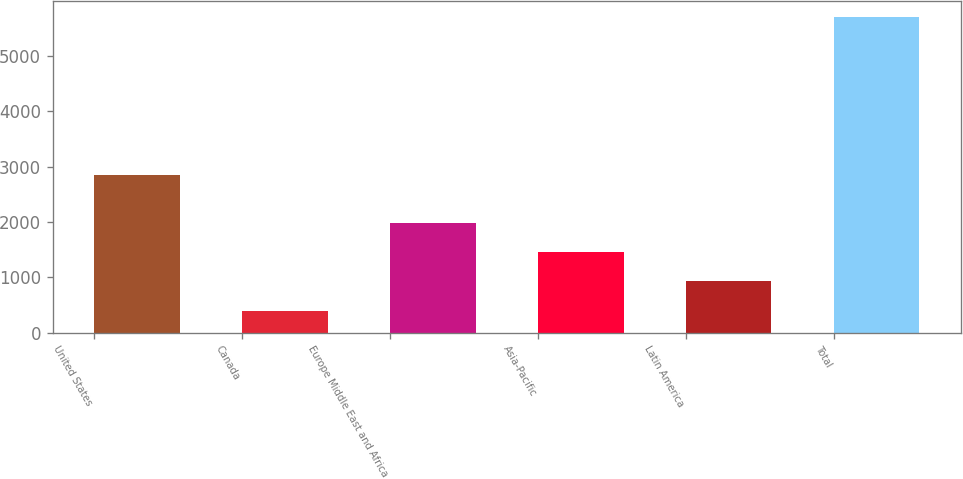<chart> <loc_0><loc_0><loc_500><loc_500><bar_chart><fcel>United States<fcel>Canada<fcel>Europe Middle East and Africa<fcel>Asia-Pacific<fcel>Latin America<fcel>Total<nl><fcel>2850.8<fcel>396.4<fcel>1986.82<fcel>1456.68<fcel>926.54<fcel>5697.8<nl></chart> 